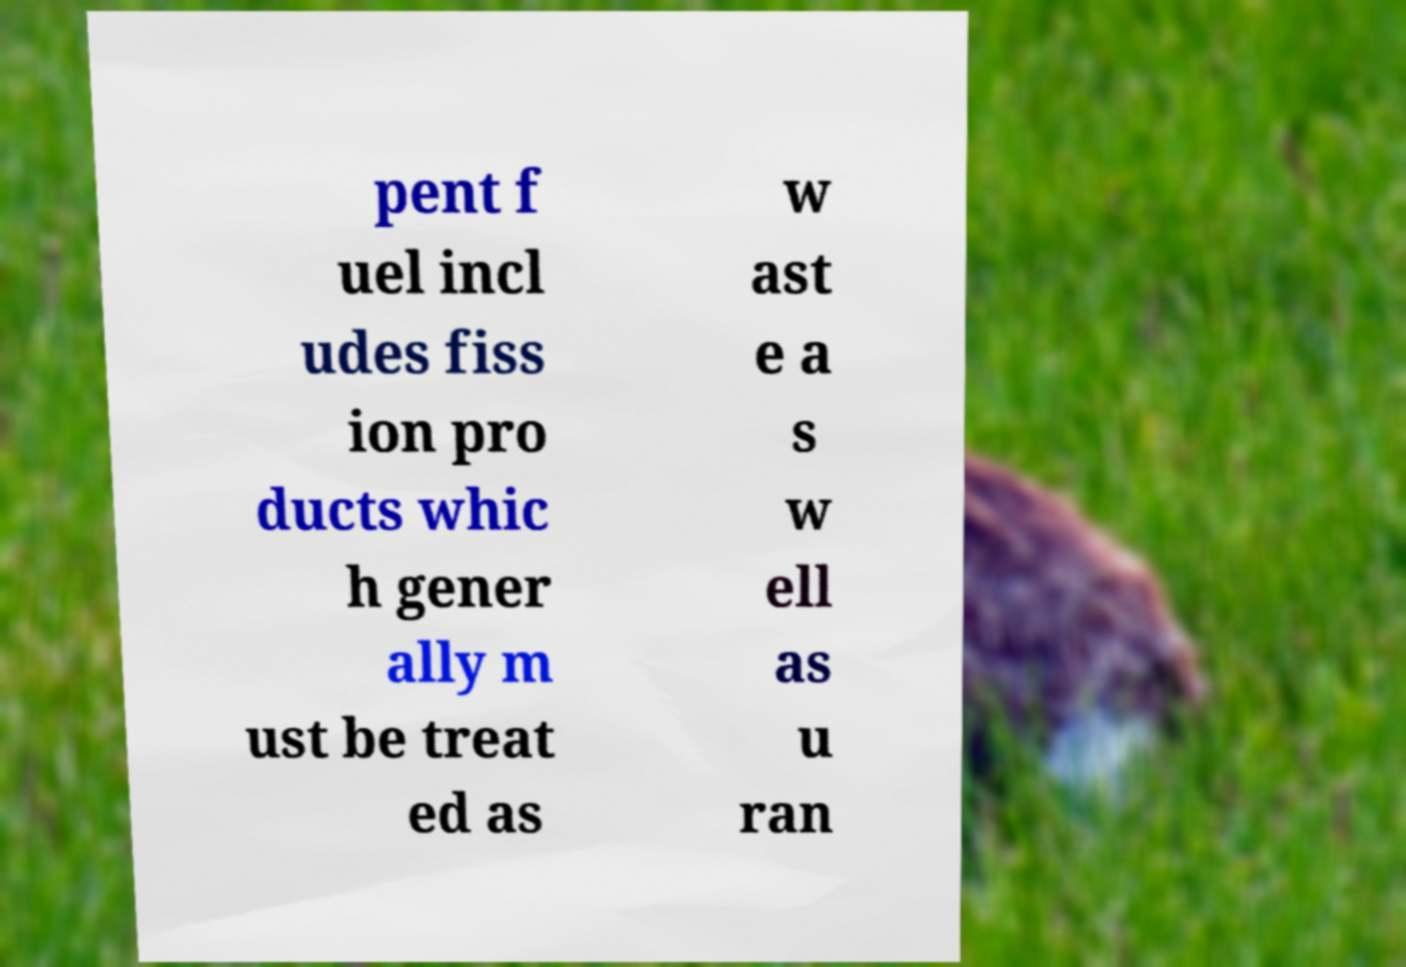Can you accurately transcribe the text from the provided image for me? pent f uel incl udes fiss ion pro ducts whic h gener ally m ust be treat ed as w ast e a s w ell as u ran 